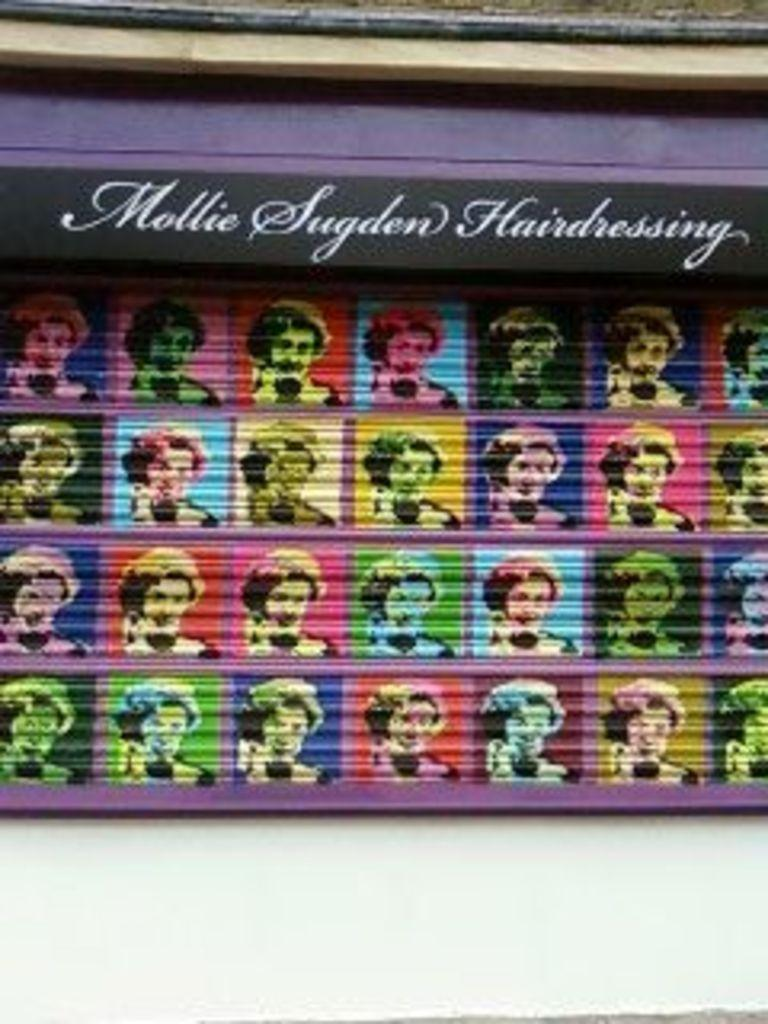What is present on the wall in the image? There is text and a group of images of a person on the wall. Can you describe the text on the wall? Unfortunately, the specific content of the text cannot be determined from the image alone. How many images of the person are present on the wall? The number of images of the person cannot be determined from the image alone. What type of tree can be seen growing on the edge of the wall in the image? There is no tree present on the edge of the wall in the image. 